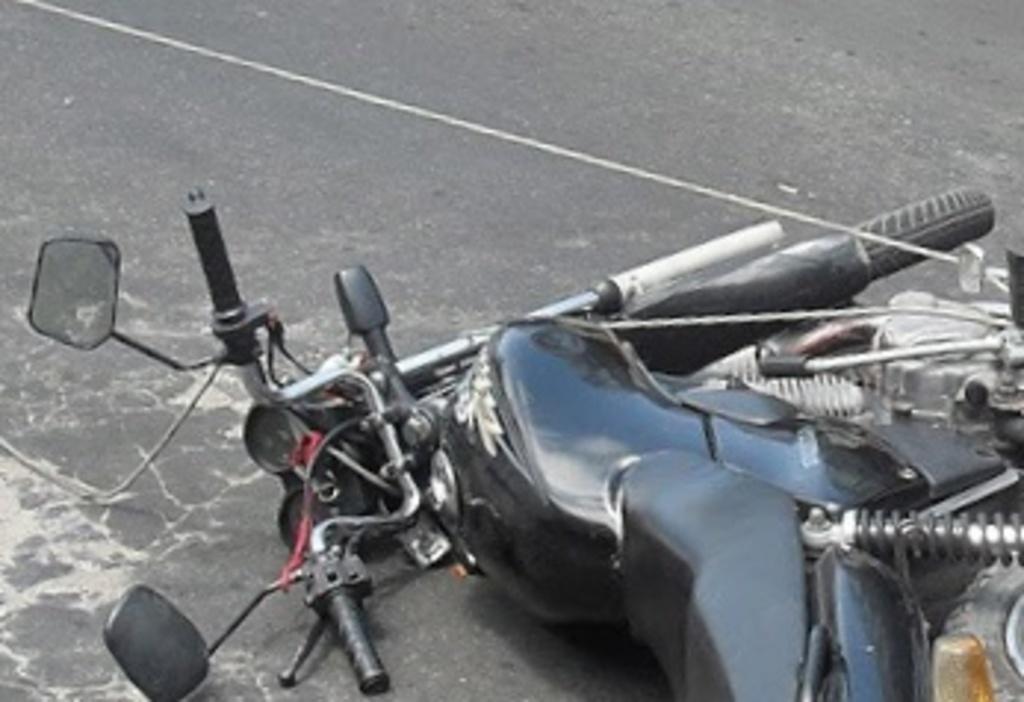In one or two sentences, can you explain what this image depicts? In this image we can see a motor vehicle fell down on the road. 